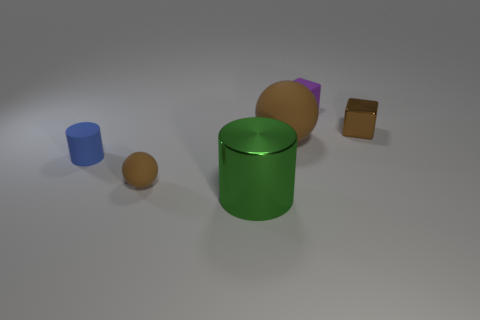Subtract all blue blocks. Subtract all purple cylinders. How many blocks are left? 2 Add 2 large red shiny objects. How many objects exist? 8 Subtract all spheres. How many objects are left? 4 Subtract all tiny brown metal blocks. Subtract all metallic cylinders. How many objects are left? 4 Add 5 tiny things. How many tiny things are left? 9 Add 2 blue things. How many blue things exist? 3 Subtract 0 yellow balls. How many objects are left? 6 